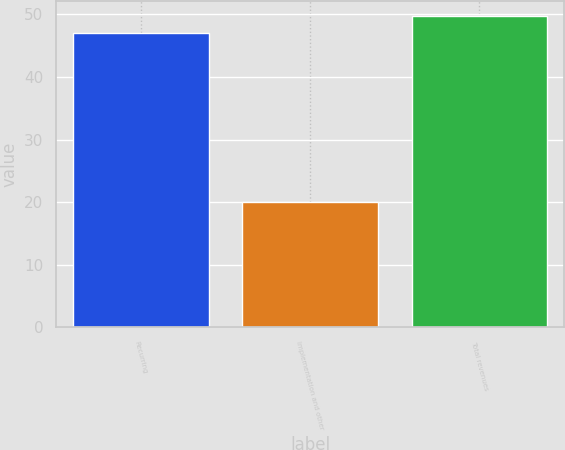Convert chart. <chart><loc_0><loc_0><loc_500><loc_500><bar_chart><fcel>Recurring<fcel>Implementation and other<fcel>Total revenues<nl><fcel>47<fcel>20<fcel>49.7<nl></chart> 